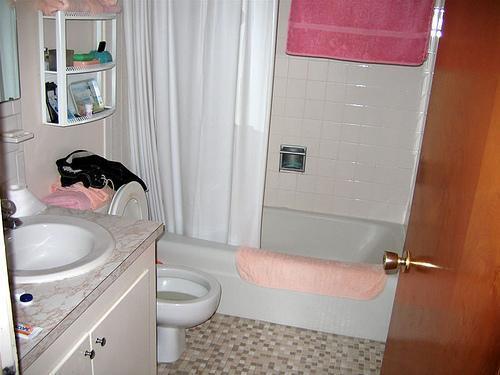How many toilets are in the photo?
Give a very brief answer. 1. 